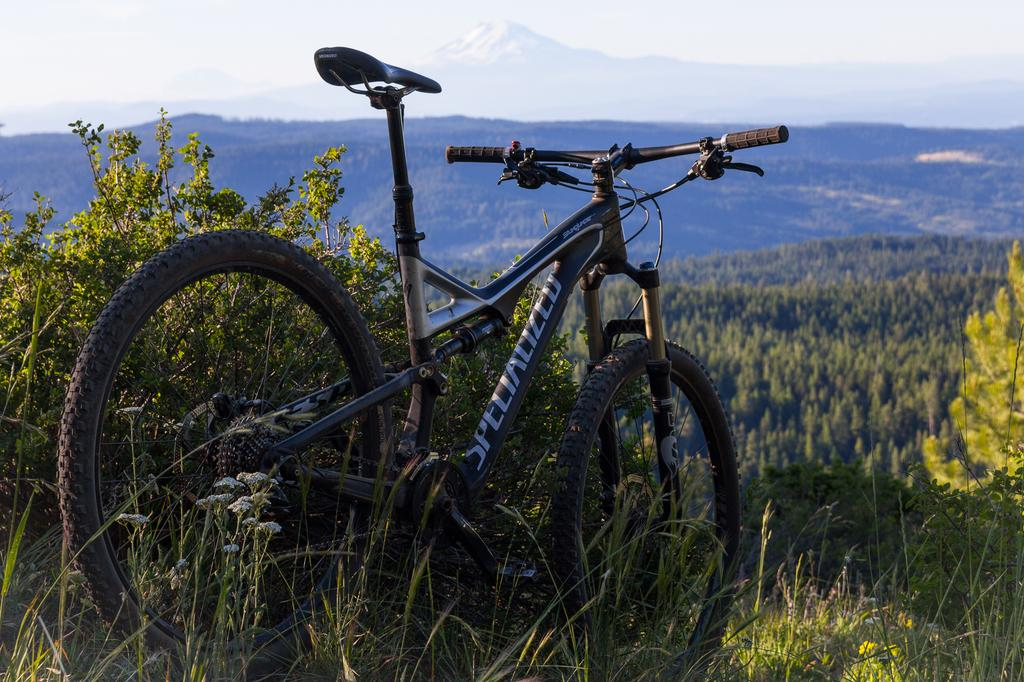What is the main object in the image? There is a bicycle in the image. Where is the bicycle located? The bicycle is parked on the grass. What else can be seen in the image besides the bicycle? There are plants in the image. What can be seen in the background of the image? Hills and the sky are visible in the background of the image. What type of can is visible on the bicycle in the image? There is no can present on the bicycle in the image. What shape is the hydrant in the image? There is no hydrant present in the image. 